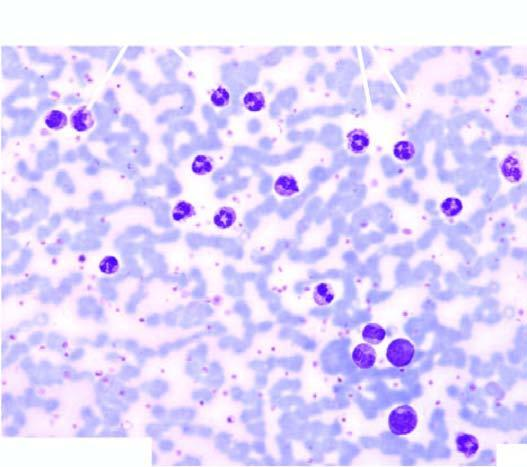s the centres of whorls of smooth muscle and connective tissue higher as demonstrated by this cytochemical stain?
Answer the question using a single word or phrase. No 